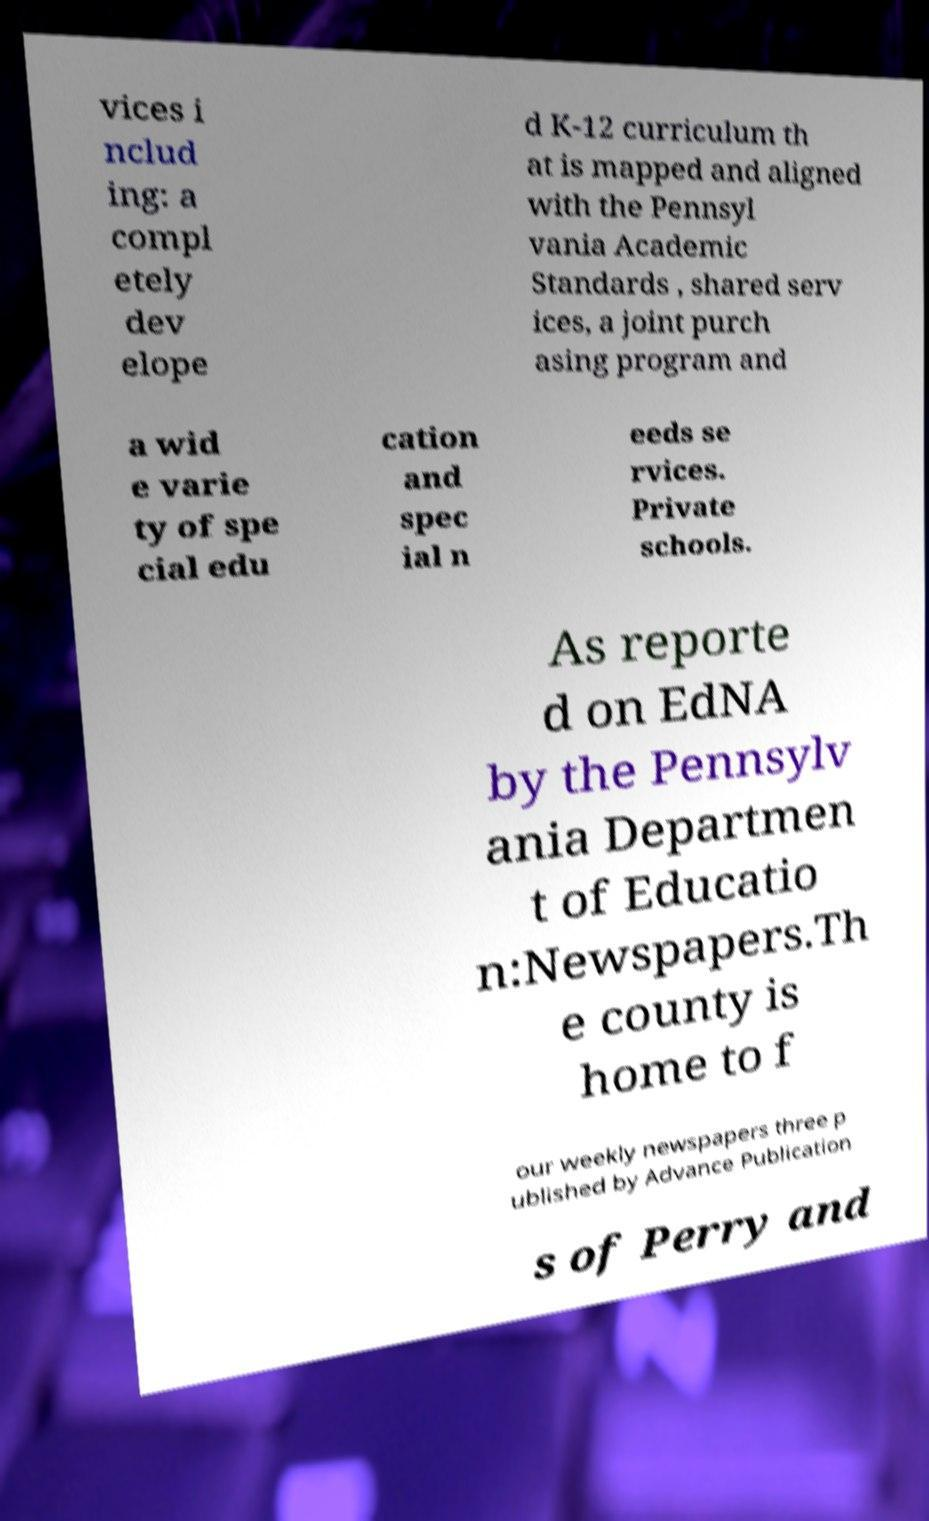What messages or text are displayed in this image? I need them in a readable, typed format. vices i nclud ing: a compl etely dev elope d K-12 curriculum th at is mapped and aligned with the Pennsyl vania Academic Standards , shared serv ices, a joint purch asing program and a wid e varie ty of spe cial edu cation and spec ial n eeds se rvices. Private schools. As reporte d on EdNA by the Pennsylv ania Departmen t of Educatio n:Newspapers.Th e county is home to f our weekly newspapers three p ublished by Advance Publication s of Perry and 